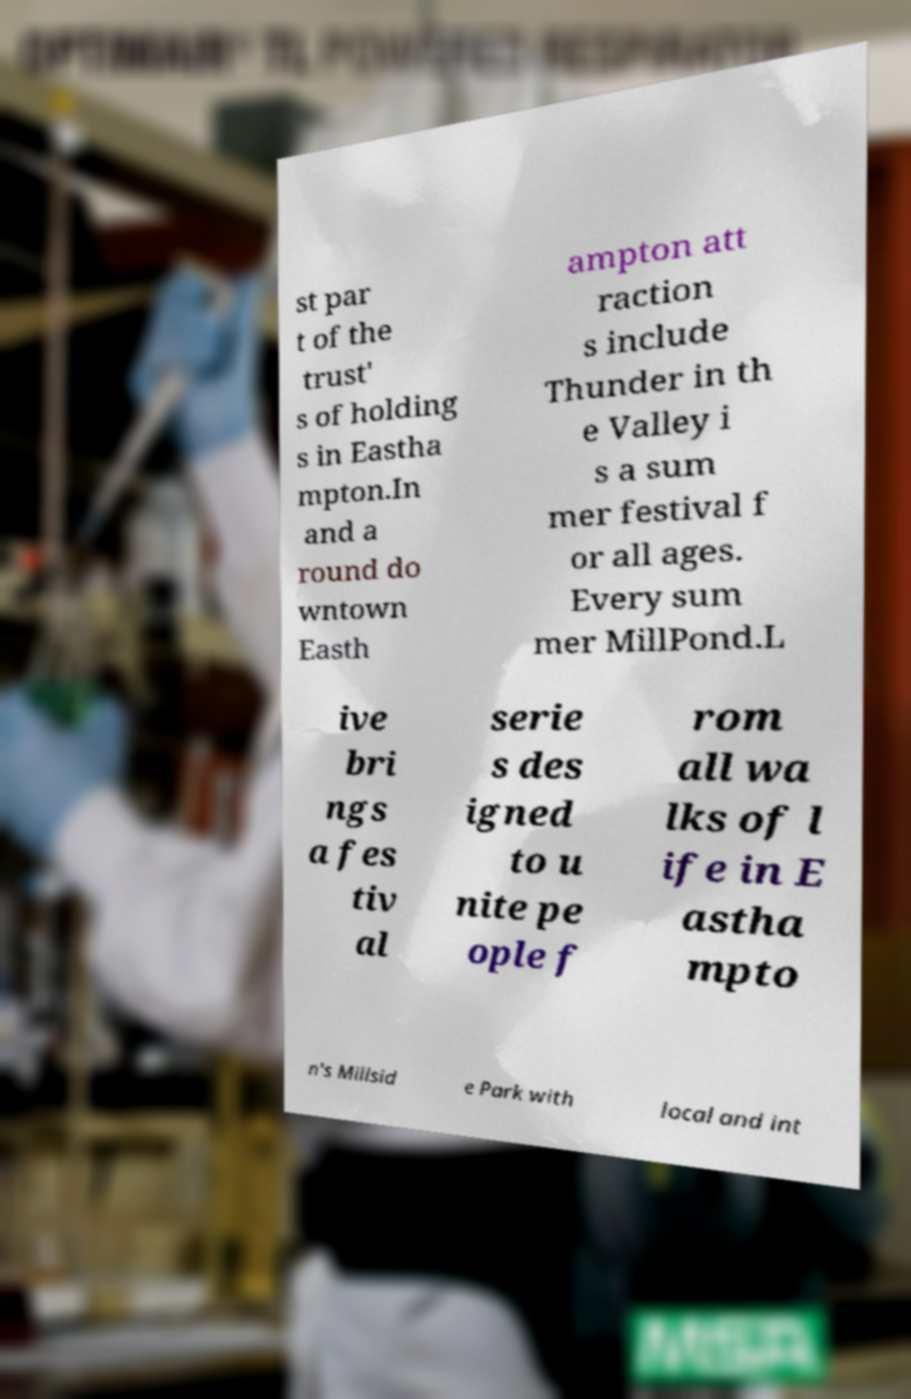Could you extract and type out the text from this image? st par t of the trust' s of holding s in Eastha mpton.In and a round do wntown Easth ampton att raction s include Thunder in th e Valley i s a sum mer festival f or all ages. Every sum mer MillPond.L ive bri ngs a fes tiv al serie s des igned to u nite pe ople f rom all wa lks of l ife in E astha mpto n's Millsid e Park with local and int 